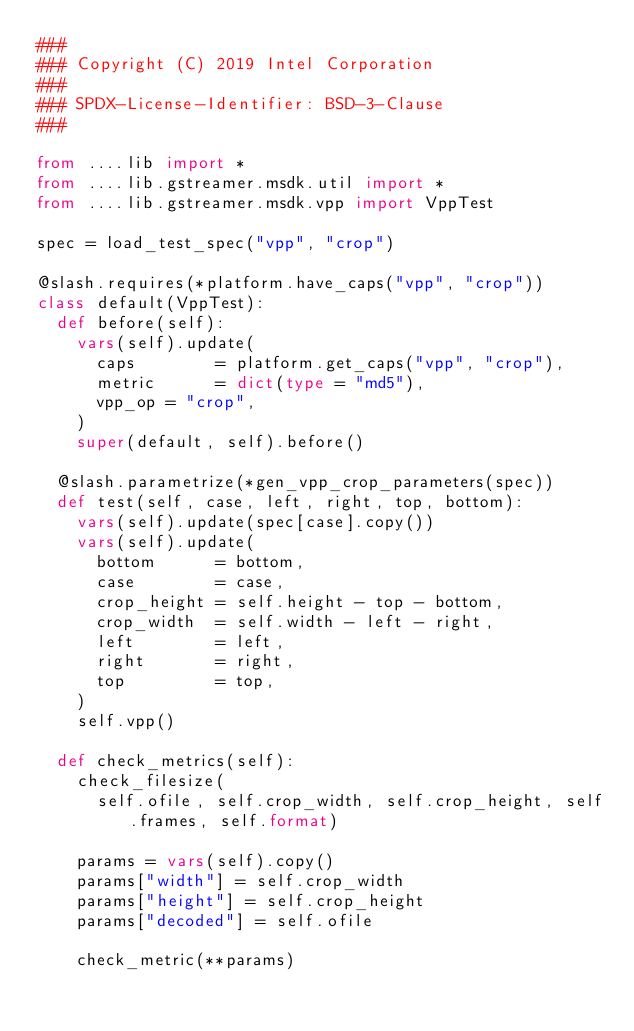<code> <loc_0><loc_0><loc_500><loc_500><_Python_>###
### Copyright (C) 2019 Intel Corporation
###
### SPDX-License-Identifier: BSD-3-Clause
###

from ....lib import *
from ....lib.gstreamer.msdk.util import *
from ....lib.gstreamer.msdk.vpp import VppTest

spec = load_test_spec("vpp", "crop")

@slash.requires(*platform.have_caps("vpp", "crop"))
class default(VppTest):
  def before(self):
    vars(self).update(
      caps        = platform.get_caps("vpp", "crop"),
      metric      = dict(type = "md5"),
      vpp_op = "crop",
    )
    super(default, self).before()

  @slash.parametrize(*gen_vpp_crop_parameters(spec))
  def test(self, case, left, right, top, bottom):
    vars(self).update(spec[case].copy())
    vars(self).update(
      bottom      = bottom,
      case        = case,
      crop_height = self.height - top - bottom,
      crop_width  = self.width - left - right,
      left        = left,
      right       = right,
      top         = top,
    )
    self.vpp()

  def check_metrics(self):
    check_filesize(
      self.ofile, self.crop_width, self.crop_height, self.frames, self.format)

    params = vars(self).copy()
    params["width"] = self.crop_width
    params["height"] = self.crop_height
    params["decoded"] = self.ofile

    check_metric(**params)
</code> 